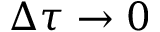<formula> <loc_0><loc_0><loc_500><loc_500>\Delta \tau \to 0</formula> 